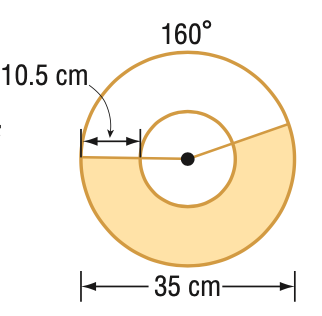Question: Find the area of the shaded region. Round to the nearest tenth.
Choices:
A. 85.5
B. 449.0
C. 534.5
D. 808.2
Answer with the letter. Answer: B 